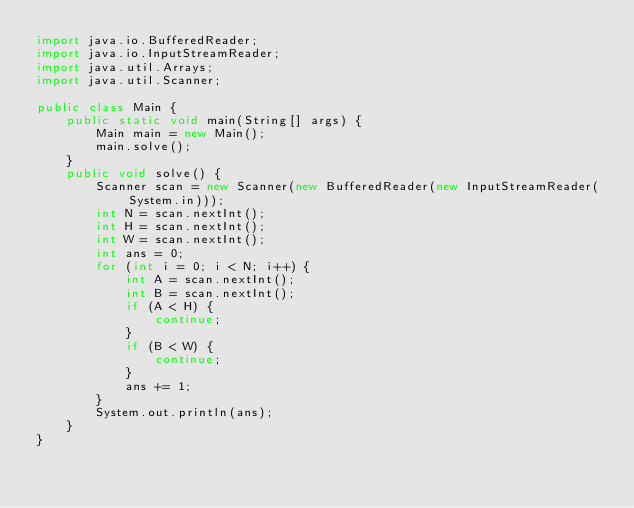<code> <loc_0><loc_0><loc_500><loc_500><_Java_>import java.io.BufferedReader;
import java.io.InputStreamReader;
import java.util.Arrays;
import java.util.Scanner;

public class Main {
    public static void main(String[] args) {
        Main main = new Main();
        main.solve();
    }
    public void solve() {
        Scanner scan = new Scanner(new BufferedReader(new InputStreamReader(System.in)));
        int N = scan.nextInt();
        int H = scan.nextInt();
        int W = scan.nextInt();
        int ans = 0;
        for (int i = 0; i < N; i++) {
            int A = scan.nextInt();
            int B = scan.nextInt();
            if (A < H) {
                continue;
            }
            if (B < W) {
                continue;
            }
            ans += 1;
        }
        System.out.println(ans);
    }
}
</code> 